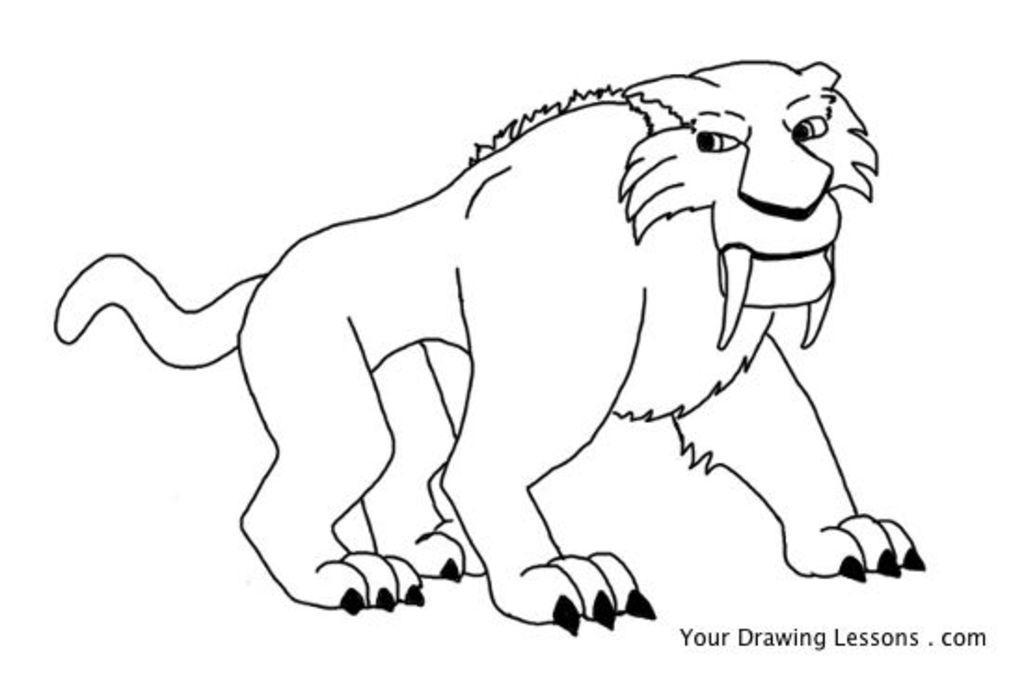Can you describe this image briefly? In this picture there is a printing page of a lion in the image. 